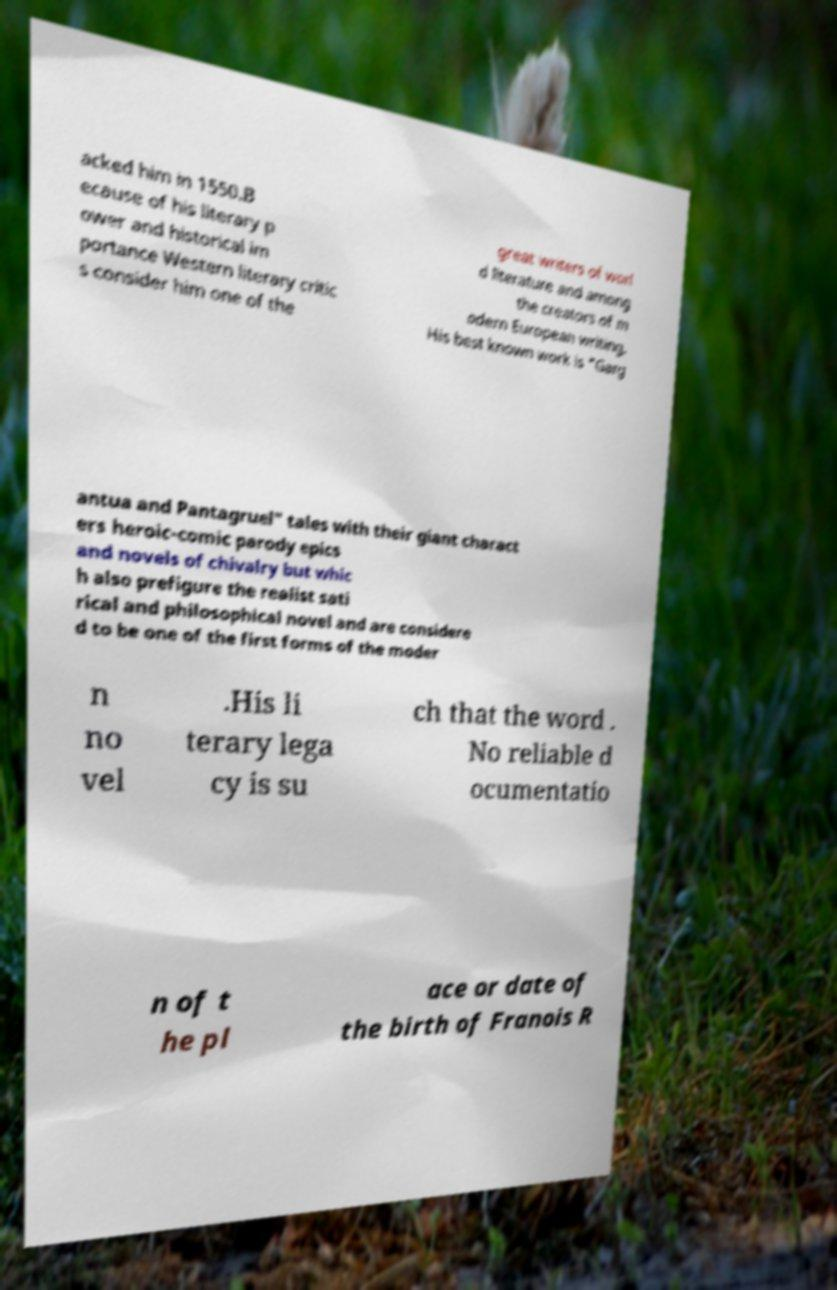I need the written content from this picture converted into text. Can you do that? acked him in 1550.B ecause of his literary p ower and historical im portance Western literary critic s consider him one of the great writers of worl d literature and among the creators of m odern European writing. His best known work is "Garg antua and Pantagruel" tales with their giant charact ers heroic-comic parody epics and novels of chivalry but whic h also prefigure the realist sati rical and philosophical novel and are considere d to be one of the first forms of the moder n no vel .His li terary lega cy is su ch that the word . No reliable d ocumentatio n of t he pl ace or date of the birth of Franois R 